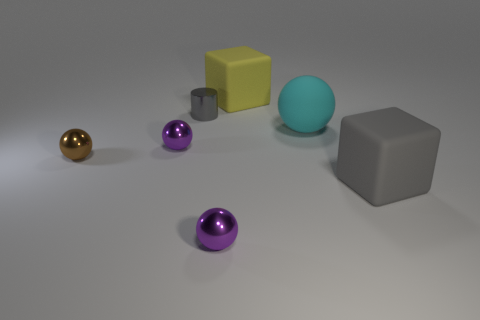Subtract all tiny balls. How many balls are left? 1 Subtract all balls. How many objects are left? 3 Subtract all cyan spheres. How many spheres are left? 3 Subtract 1 cyan balls. How many objects are left? 6 Subtract 1 blocks. How many blocks are left? 1 Subtract all brown cylinders. Subtract all blue cubes. How many cylinders are left? 1 Subtract all purple spheres. How many yellow blocks are left? 1 Subtract all tiny purple shiny objects. Subtract all matte spheres. How many objects are left? 4 Add 3 brown spheres. How many brown spheres are left? 4 Add 3 tiny gray things. How many tiny gray things exist? 4 